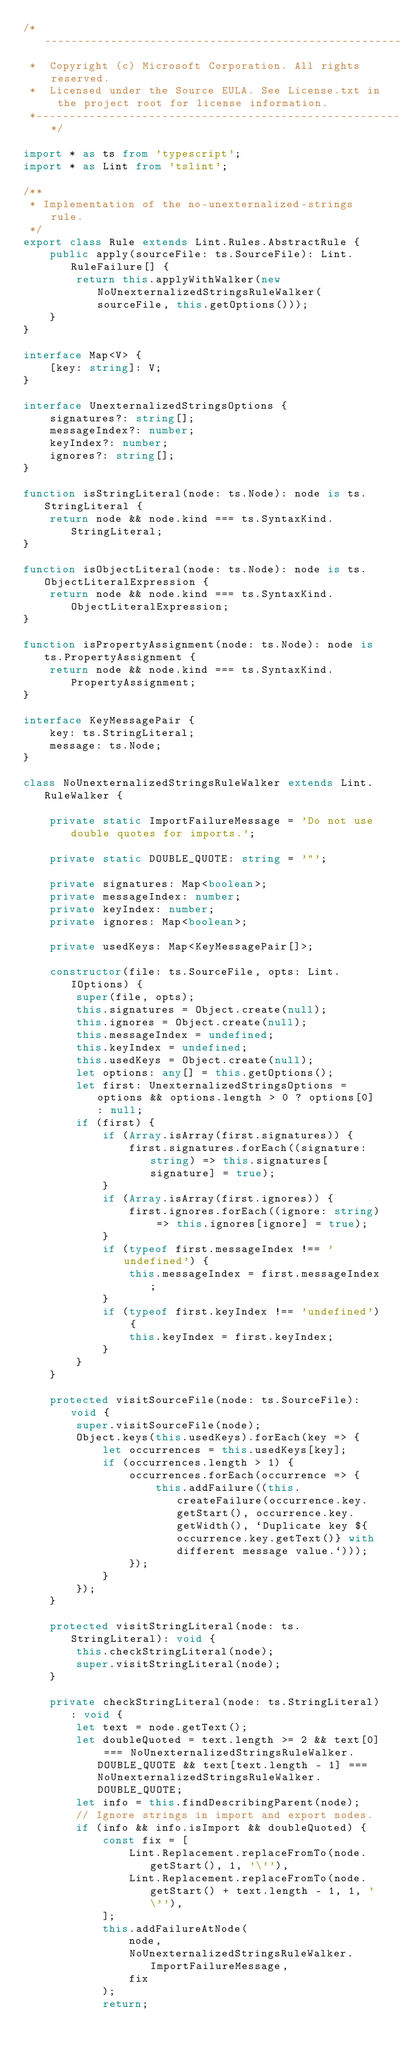<code> <loc_0><loc_0><loc_500><loc_500><_TypeScript_>/*---------------------------------------------------------------------------------------------
 *  Copyright (c) Microsoft Corporation. All rights reserved.
 *  Licensed under the Source EULA. See License.txt in the project root for license information.
 *--------------------------------------------------------------------------------------------*/

import * as ts from 'typescript';
import * as Lint from 'tslint';

/**
 * Implementation of the no-unexternalized-strings rule.
 */
export class Rule extends Lint.Rules.AbstractRule {
	public apply(sourceFile: ts.SourceFile): Lint.RuleFailure[] {
		return this.applyWithWalker(new NoUnexternalizedStringsRuleWalker(sourceFile, this.getOptions()));
	}
}

interface Map<V> {
	[key: string]: V;
}

interface UnexternalizedStringsOptions {
	signatures?: string[];
	messageIndex?: number;
	keyIndex?: number;
	ignores?: string[];
}

function isStringLiteral(node: ts.Node): node is ts.StringLiteral {
	return node && node.kind === ts.SyntaxKind.StringLiteral;
}

function isObjectLiteral(node: ts.Node): node is ts.ObjectLiteralExpression {
	return node && node.kind === ts.SyntaxKind.ObjectLiteralExpression;
}

function isPropertyAssignment(node: ts.Node): node is ts.PropertyAssignment {
	return node && node.kind === ts.SyntaxKind.PropertyAssignment;
}

interface KeyMessagePair {
	key: ts.StringLiteral;
	message: ts.Node;
}

class NoUnexternalizedStringsRuleWalker extends Lint.RuleWalker {

	private static ImportFailureMessage = 'Do not use double quotes for imports.';

	private static DOUBLE_QUOTE: string = '"';

	private signatures: Map<boolean>;
	private messageIndex: number;
	private keyIndex: number;
	private ignores: Map<boolean>;

	private usedKeys: Map<KeyMessagePair[]>;

	constructor(file: ts.SourceFile, opts: Lint.IOptions) {
		super(file, opts);
		this.signatures = Object.create(null);
		this.ignores = Object.create(null);
		this.messageIndex = undefined;
		this.keyIndex = undefined;
		this.usedKeys = Object.create(null);
		let options: any[] = this.getOptions();
		let first: UnexternalizedStringsOptions = options && options.length > 0 ? options[0] : null;
		if (first) {
			if (Array.isArray(first.signatures)) {
				first.signatures.forEach((signature: string) => this.signatures[signature] = true);
			}
			if (Array.isArray(first.ignores)) {
				first.ignores.forEach((ignore: string) => this.ignores[ignore] = true);
			}
			if (typeof first.messageIndex !== 'undefined') {
				this.messageIndex = first.messageIndex;
			}
			if (typeof first.keyIndex !== 'undefined') {
				this.keyIndex = first.keyIndex;
			}
		}
	}

	protected visitSourceFile(node: ts.SourceFile): void {
		super.visitSourceFile(node);
		Object.keys(this.usedKeys).forEach(key => {
			let occurrences = this.usedKeys[key];
			if (occurrences.length > 1) {
				occurrences.forEach(occurrence => {
					this.addFailure((this.createFailure(occurrence.key.getStart(), occurrence.key.getWidth(), `Duplicate key ${occurrence.key.getText()} with different message value.`)));
				});
			}
		});
	}

	protected visitStringLiteral(node: ts.StringLiteral): void {
		this.checkStringLiteral(node);
		super.visitStringLiteral(node);
	}

	private checkStringLiteral(node: ts.StringLiteral): void {
		let text = node.getText();
		let doubleQuoted = text.length >= 2 && text[0] === NoUnexternalizedStringsRuleWalker.DOUBLE_QUOTE && text[text.length - 1] === NoUnexternalizedStringsRuleWalker.DOUBLE_QUOTE;
		let info = this.findDescribingParent(node);
		// Ignore strings in import and export nodes.
		if (info && info.isImport && doubleQuoted) {
			const fix = [
				Lint.Replacement.replaceFromTo(node.getStart(), 1, '\''),
				Lint.Replacement.replaceFromTo(node.getStart() + text.length - 1, 1, '\''),
			];
			this.addFailureAtNode(
				node,
				NoUnexternalizedStringsRuleWalker.ImportFailureMessage,
				fix
			);
			return;</code> 